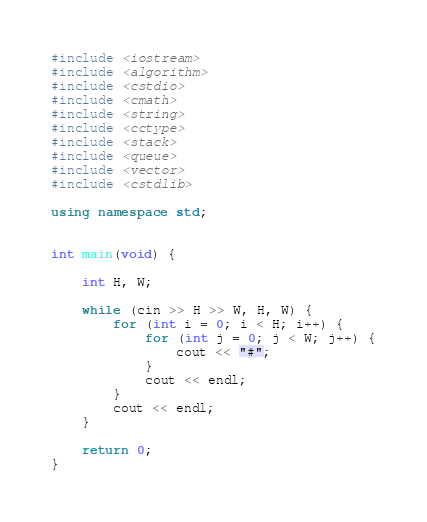<code> <loc_0><loc_0><loc_500><loc_500><_C++_>#include <iostream>
#include <algorithm>
#include <cstdio>
#include <cmath>
#include <string>
#include <cctype>
#include <stack>
#include <queue>
#include <vector>
#include <cstdlib>

using namespace std;


int main(void) {

	int H, W;

	while (cin >> H >> W, H, W) {
		for (int i = 0; i < H; i++) {
			for (int j = 0; j < W; j++) {
				cout << "#";
			}
			cout << endl;
		}
		cout << endl;
	}

	return 0;
}</code> 